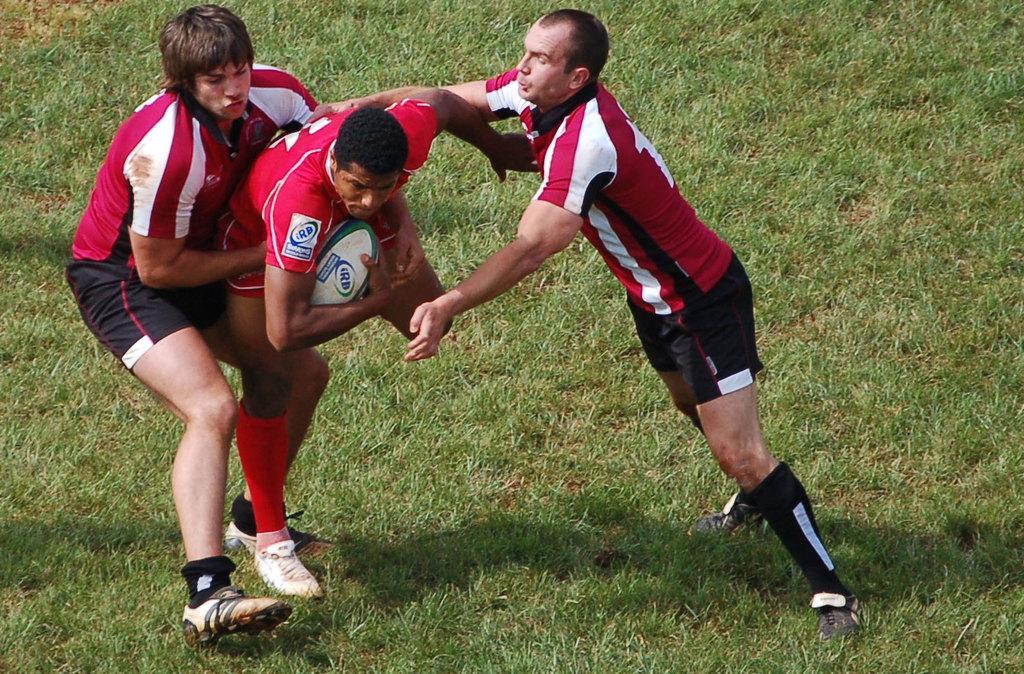Describe this image in one or two sentences. In this image I can see three people are wearing red,white and black color dresses. One person is holding a ball. I can see the green grass. 